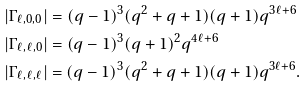Convert formula to latex. <formula><loc_0><loc_0><loc_500><loc_500>& | \Gamma _ { \ell , 0 , 0 } | = ( q - 1 ) ^ { 3 } ( q ^ { 2 } + q + 1 ) ( q + 1 ) q ^ { 3 \ell + 6 } \\ & | \Gamma _ { \ell , \ell , 0 } | = ( q - 1 ) ^ { 3 } ( q + 1 ) ^ { 2 } q ^ { 4 \ell + 6 } \\ & | \Gamma _ { \ell , \ell , \ell } | = ( q - 1 ) ^ { 3 } ( q ^ { 2 } + q + 1 ) ( q + 1 ) q ^ { 3 \ell + 6 } .</formula> 